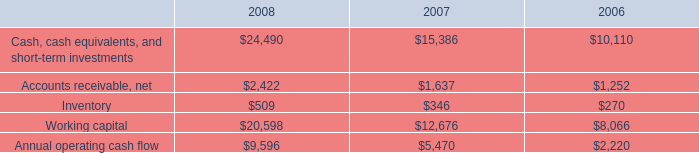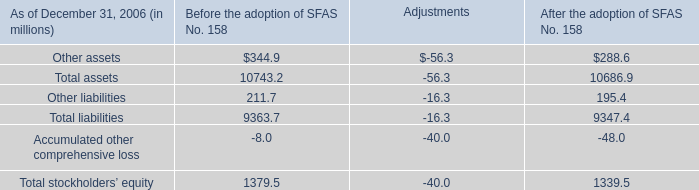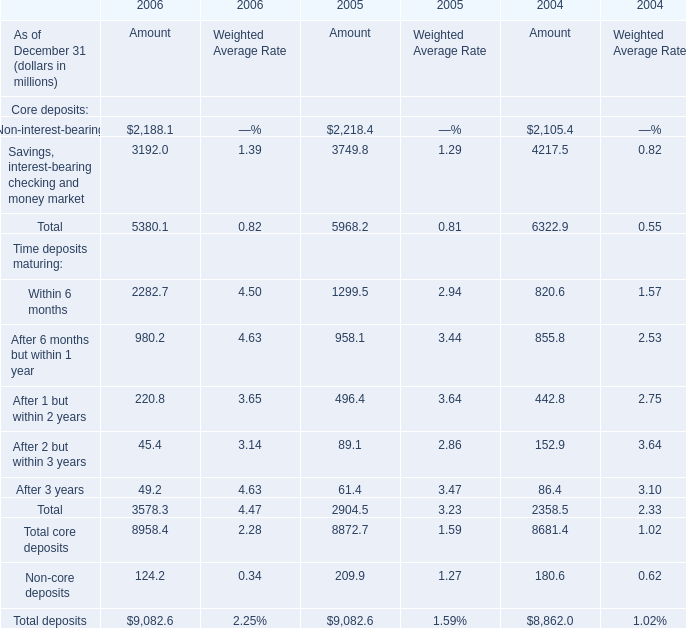What's the increasing rate of Savings, interest-bearing checking and money market in 2006? (in %) 
Computations: ((3192 - 3749.8) / 3749.8)
Answer: -0.14875. 